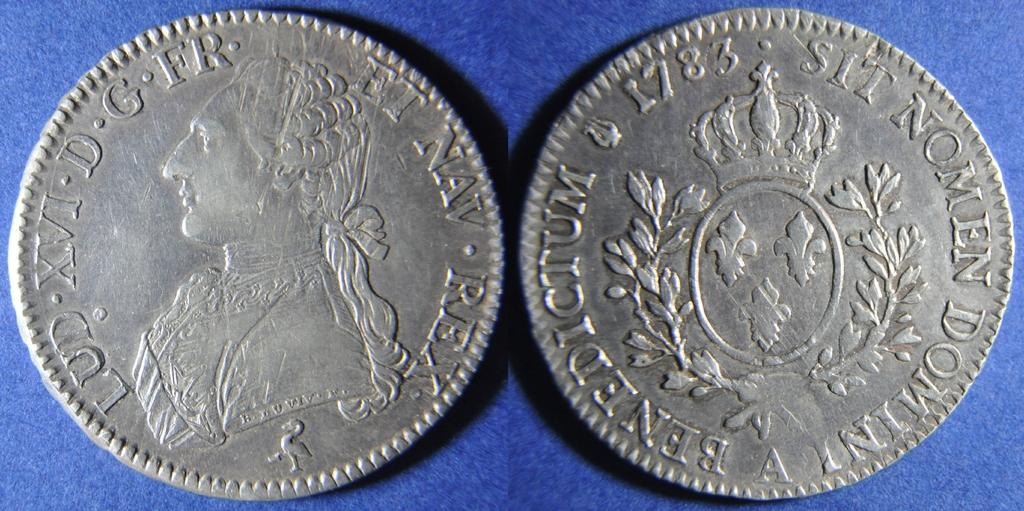What objects are present in the image? There are two coins in the image. How are the coins positioned in relation to each other? The coins are placed beside each other. What is the color of the floor in the image? The floor in the image is blue in color. What is the texture of the uncle's shirt in the image? There is no uncle or shirt present in the image; it only features two coins and a blue floor. 